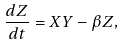<formula> <loc_0><loc_0><loc_500><loc_500>\frac { d Z } { d t } = X Y - \beta Z ,</formula> 